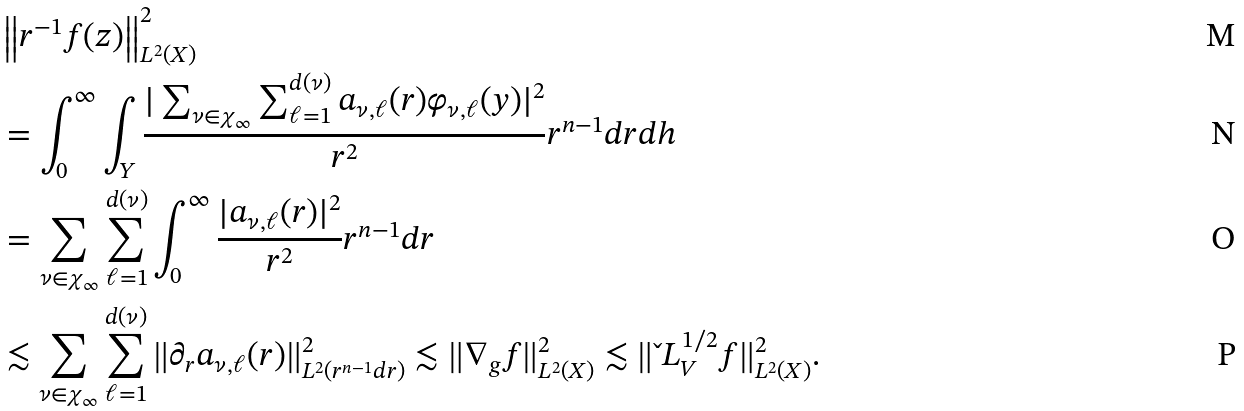Convert formula to latex. <formula><loc_0><loc_0><loc_500><loc_500>& \left \| r ^ { - 1 } f ( z ) \right \| ^ { 2 } _ { L ^ { 2 } ( X ) } \\ & = \int _ { 0 } ^ { \infty } \int _ { Y } \frac { | \sum _ { \nu \in \chi _ { \infty } } \sum _ { \ell = 1 } ^ { d ( \nu ) } a _ { \nu , \ell } ( r ) \varphi _ { \nu , \ell } ( y ) | ^ { 2 } } { r ^ { 2 } } r ^ { n - 1 } d r d h \\ & = \sum _ { \nu \in \chi _ { \infty } } \sum _ { \ell = 1 } ^ { d ( \nu ) } \int _ { 0 } ^ { \infty } \frac { | a _ { \nu , \ell } ( r ) | ^ { 2 } } { r ^ { 2 } } r ^ { n - 1 } d r \\ & \lesssim \sum _ { \nu \in \chi _ { \infty } } \sum _ { \ell = 1 } ^ { d ( \nu ) } \| \partial _ { r } a _ { \nu , \ell } ( r ) \| ^ { 2 } _ { L ^ { 2 } ( r ^ { n - 1 } d r ) } \lesssim \| \nabla _ { g } f \| ^ { 2 } _ { L ^ { 2 } ( X ) } \lesssim \| \L L _ { V } ^ { 1 / 2 } f \| ^ { 2 } _ { L ^ { 2 } ( X ) } .</formula> 